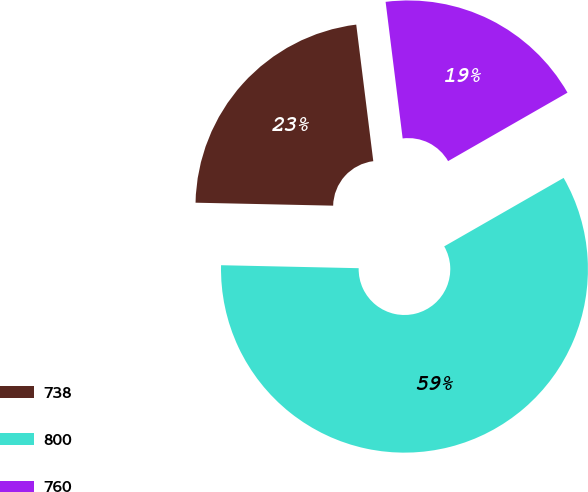Convert chart. <chart><loc_0><loc_0><loc_500><loc_500><pie_chart><fcel>738<fcel>800<fcel>760<nl><fcel>22.68%<fcel>58.63%<fcel>18.69%<nl></chart> 